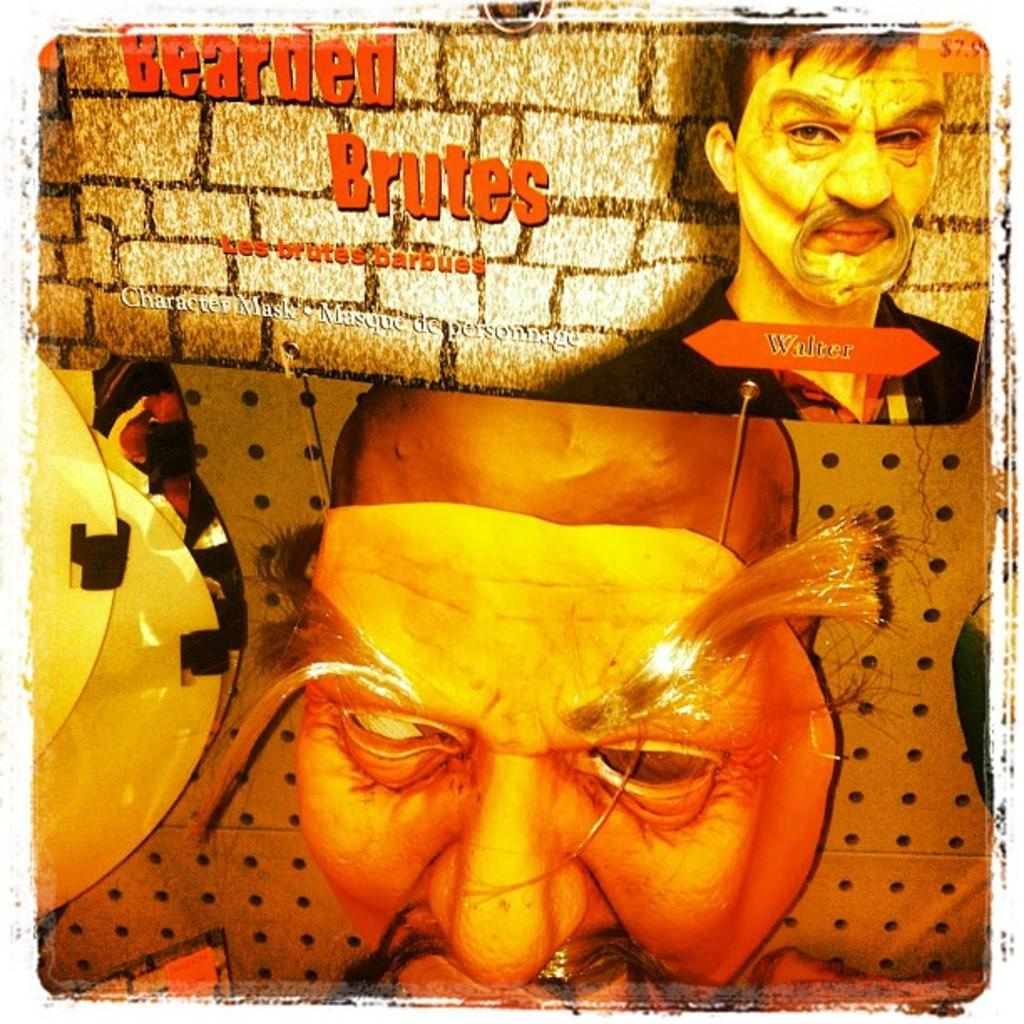What is the main subject of the image? The main subject of the image is a poster. What is shown on the poster? There are people depicted on the poster. What else can be found on the poster besides the images of people? There is some information present on the poster. What is the tendency of the hammer in the image? There is no hammer present in the image. How does the show proceed in the image? There is no show depicted in the image; it is a picture of a poster. 